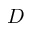<formula> <loc_0><loc_0><loc_500><loc_500>D</formula> 